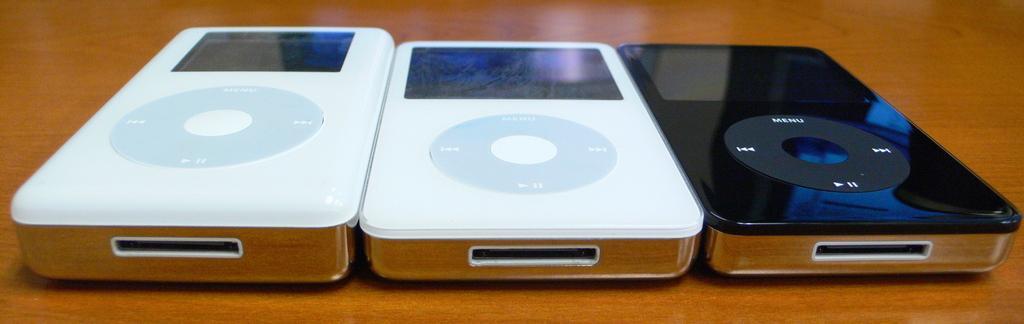In one or two sentences, can you explain what this image depicts? In this image there are electronic objects which are white and black in colour, which is on the surface, which is brown in colour. 